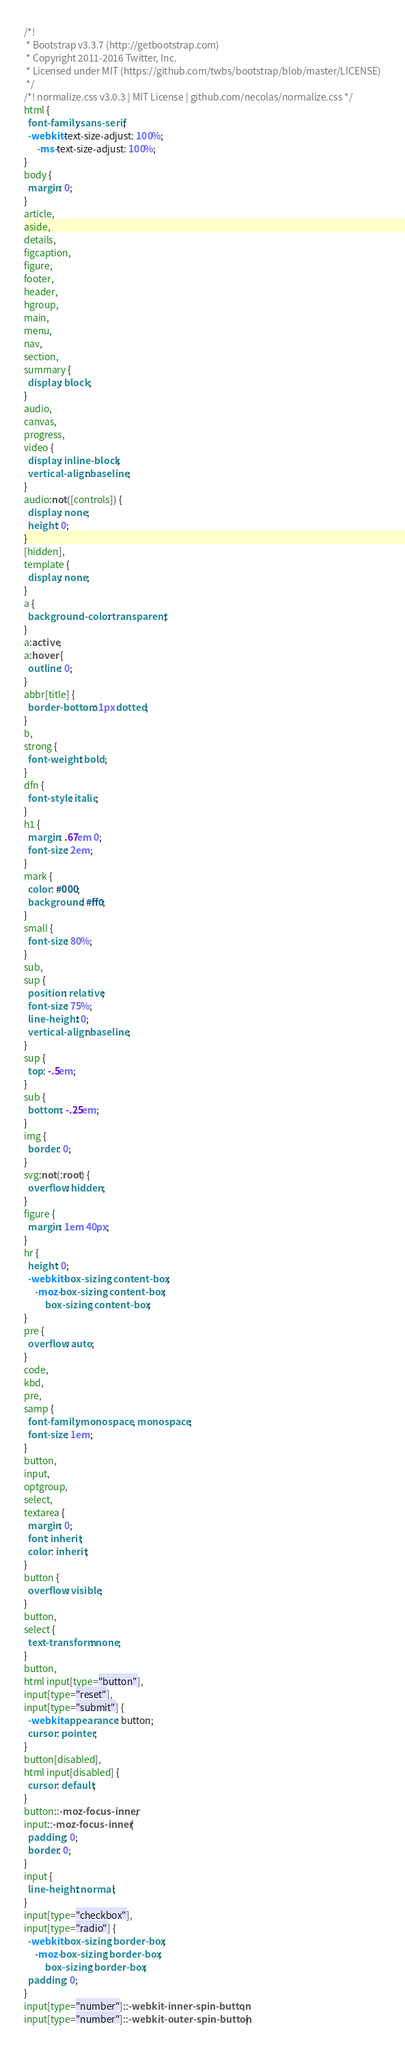<code> <loc_0><loc_0><loc_500><loc_500><_CSS_>/*!
 * Bootstrap v3.3.7 (http://getbootstrap.com)
 * Copyright 2011-2016 Twitter, Inc.
 * Licensed under MIT (https://github.com/twbs/bootstrap/blob/master/LICENSE)
 */
/*! normalize.css v3.0.3 | MIT License | github.com/necolas/normalize.css */
html {
  font-family: sans-serif;
  -webkit-text-size-adjust: 100%;
      -ms-text-size-adjust: 100%;
}
body {
  margin: 0;
}
article,
aside,
details,
figcaption,
figure,
footer,
header,
hgroup,
main,
menu,
nav,
section,
summary {
  display: block;
}
audio,
canvas,
progress,
video {
  display: inline-block;
  vertical-align: baseline;
}
audio:not([controls]) {
  display: none;
  height: 0;
}
[hidden],
template {
  display: none;
}
a {
  background-color: transparent;
}
a:active,
a:hover {
  outline: 0;
}
abbr[title] {
  border-bottom: 1px dotted;
}
b,
strong {
  font-weight: bold;
}
dfn {
  font-style: italic;
}
h1 {
  margin: .67em 0;
  font-size: 2em;
}
mark {
  color: #000;
  background: #ff0;
}
small {
  font-size: 80%;
}
sub,
sup {
  position: relative;
  font-size: 75%;
  line-height: 0;
  vertical-align: baseline;
}
sup {
  top: -.5em;
}
sub {
  bottom: -.25em;
}
img {
  border: 0;
}
svg:not(:root) {
  overflow: hidden;
}
figure {
  margin: 1em 40px;
}
hr {
  height: 0;
  -webkit-box-sizing: content-box;
     -moz-box-sizing: content-box;
          box-sizing: content-box;
}
pre {
  overflow: auto;
}
code,
kbd,
pre,
samp {
  font-family: monospace, monospace;
  font-size: 1em;
}
button,
input,
optgroup,
select,
textarea {
  margin: 0;
  font: inherit;
  color: inherit;
}
button {
  overflow: visible;
}
button,
select {
  text-transform: none;
}
button,
html input[type="button"],
input[type="reset"],
input[type="submit"] {
  -webkit-appearance: button;
  cursor: pointer;
}
button[disabled],
html input[disabled] {
  cursor: default;
}
button::-moz-focus-inner,
input::-moz-focus-inner {
  padding: 0;
  border: 0;
}
input {
  line-height: normal;
}
input[type="checkbox"],
input[type="radio"] {
  -webkit-box-sizing: border-box;
     -moz-box-sizing: border-box;
          box-sizing: border-box;
  padding: 0;
}
input[type="number"]::-webkit-inner-spin-button,
input[type="number"]::-webkit-outer-spin-button {</code> 